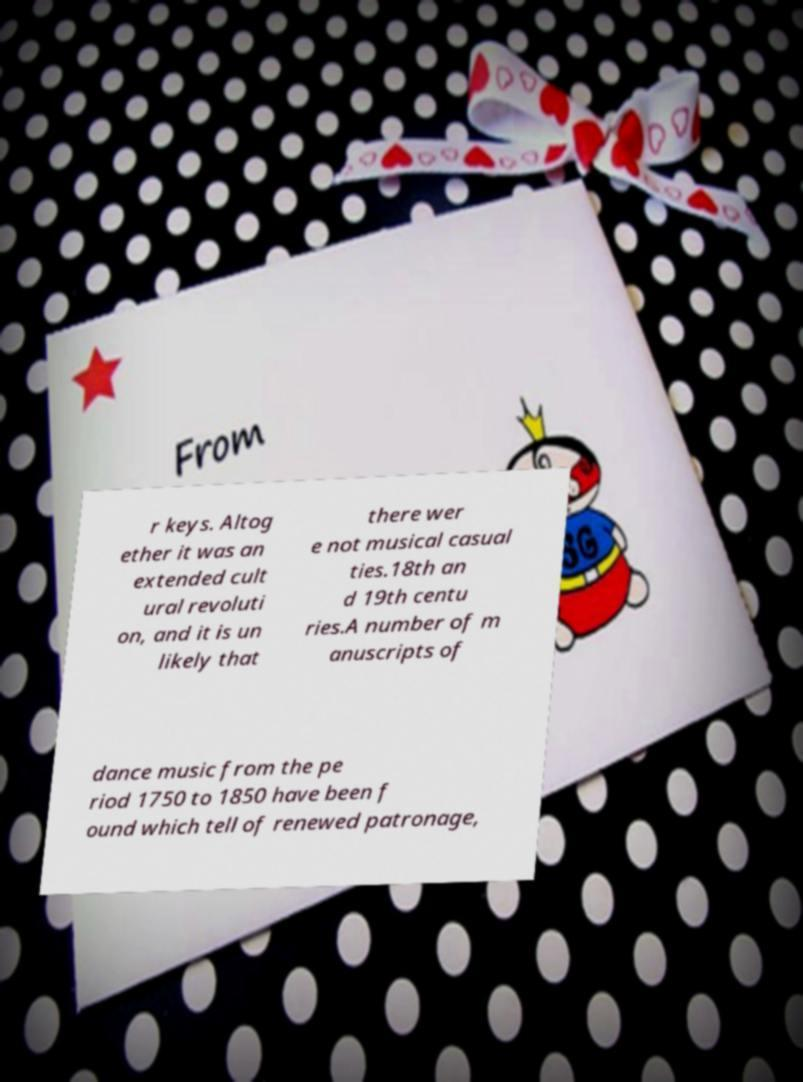Could you assist in decoding the text presented in this image and type it out clearly? r keys. Altog ether it was an extended cult ural revoluti on, and it is un likely that there wer e not musical casual ties.18th an d 19th centu ries.A number of m anuscripts of dance music from the pe riod 1750 to 1850 have been f ound which tell of renewed patronage, 